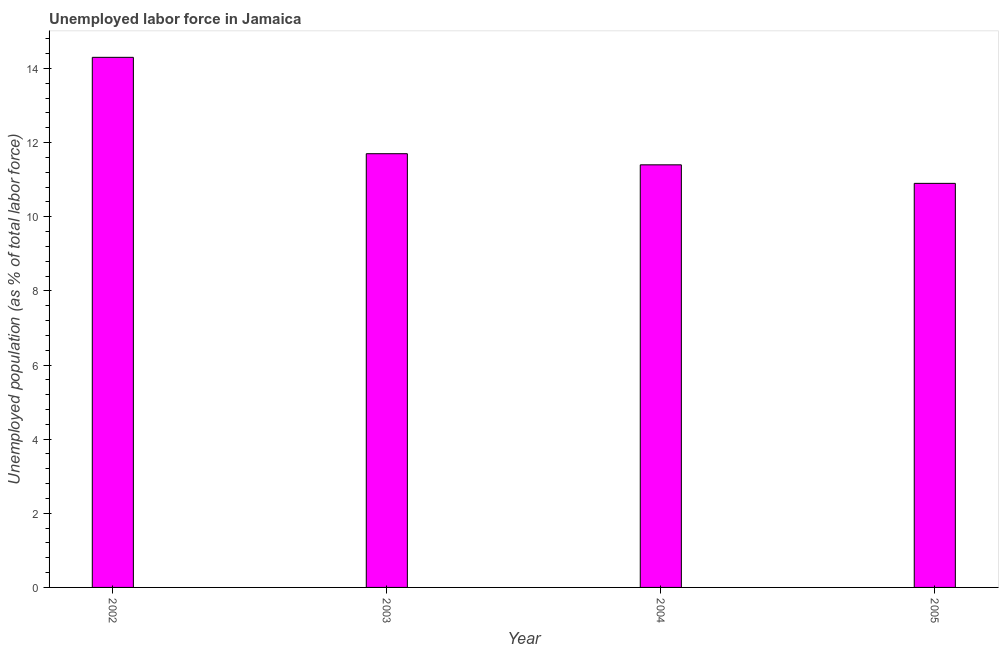Does the graph contain any zero values?
Offer a very short reply. No. Does the graph contain grids?
Your response must be concise. No. What is the title of the graph?
Make the answer very short. Unemployed labor force in Jamaica. What is the label or title of the X-axis?
Provide a succinct answer. Year. What is the label or title of the Y-axis?
Keep it short and to the point. Unemployed population (as % of total labor force). What is the total unemployed population in 2002?
Offer a very short reply. 14.3. Across all years, what is the maximum total unemployed population?
Keep it short and to the point. 14.3. Across all years, what is the minimum total unemployed population?
Your answer should be compact. 10.9. In which year was the total unemployed population minimum?
Make the answer very short. 2005. What is the sum of the total unemployed population?
Offer a very short reply. 48.3. What is the average total unemployed population per year?
Your answer should be compact. 12.07. What is the median total unemployed population?
Give a very brief answer. 11.55. What is the difference between the highest and the lowest total unemployed population?
Offer a terse response. 3.4. How many bars are there?
Offer a terse response. 4. How many years are there in the graph?
Ensure brevity in your answer.  4. What is the difference between two consecutive major ticks on the Y-axis?
Provide a short and direct response. 2. What is the Unemployed population (as % of total labor force) of 2002?
Offer a very short reply. 14.3. What is the Unemployed population (as % of total labor force) in 2003?
Keep it short and to the point. 11.7. What is the Unemployed population (as % of total labor force) in 2004?
Give a very brief answer. 11.4. What is the Unemployed population (as % of total labor force) in 2005?
Offer a very short reply. 10.9. What is the difference between the Unemployed population (as % of total labor force) in 2002 and 2004?
Your answer should be very brief. 2.9. What is the difference between the Unemployed population (as % of total labor force) in 2003 and 2005?
Your response must be concise. 0.8. What is the ratio of the Unemployed population (as % of total labor force) in 2002 to that in 2003?
Offer a very short reply. 1.22. What is the ratio of the Unemployed population (as % of total labor force) in 2002 to that in 2004?
Provide a succinct answer. 1.25. What is the ratio of the Unemployed population (as % of total labor force) in 2002 to that in 2005?
Ensure brevity in your answer.  1.31. What is the ratio of the Unemployed population (as % of total labor force) in 2003 to that in 2004?
Your response must be concise. 1.03. What is the ratio of the Unemployed population (as % of total labor force) in 2003 to that in 2005?
Ensure brevity in your answer.  1.07. What is the ratio of the Unemployed population (as % of total labor force) in 2004 to that in 2005?
Provide a succinct answer. 1.05. 